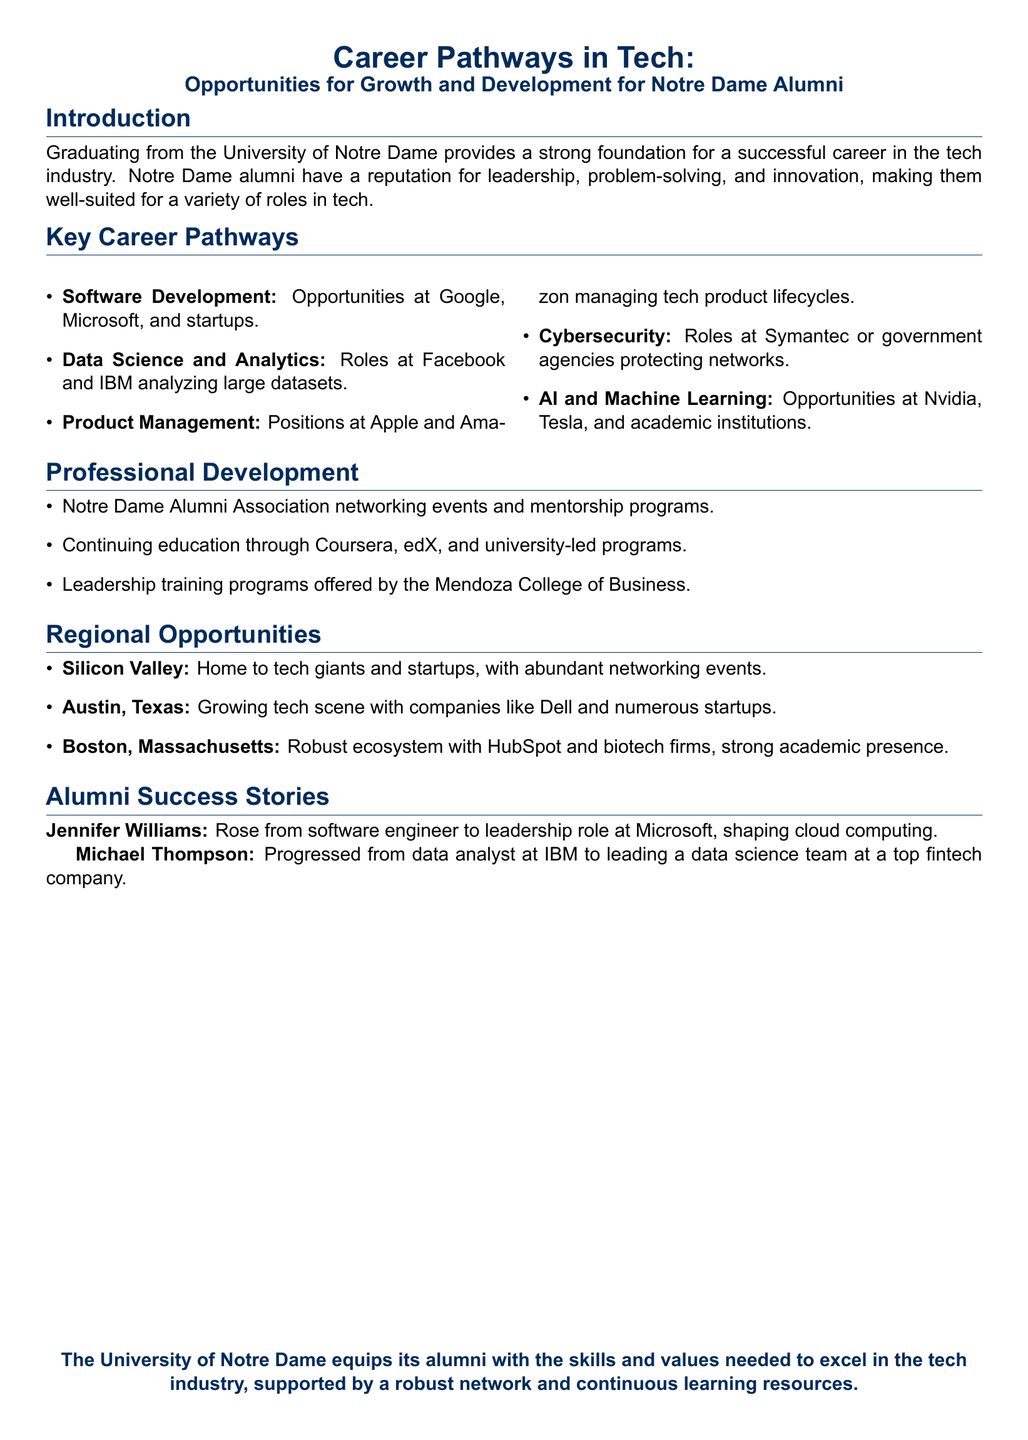What is a key career pathway in tech according to the document? The document lists multiple key career pathways such as Software Development, Data Science and Analytics, etc.
Answer: Software Development Which company is mentioned for opportunities in AI and Machine Learning? The document names specific companies associated with AI and Machine Learning roles, including Nvidia and Tesla.
Answer: Nvidia What type of training programs does the Mendoza College of Business offer? The document refers to specific programs available for professional development, such as leadership training.
Answer: Leadership training Who progressed from a data analyst to a data science team leader? The document highlights specific alumni success stories, including their career progression at notable companies.
Answer: Michael Thompson Which state is recognized for its growing tech scene? The document identifies regions known for tech opportunities, including Austin, Texas, as one of them.
Answer: Texas What is the focus of mentorship programs mentioned in the document? The document emphasizes networking events and mentorship resources available through the Notre Dame Alumni Association.
Answer: Networking How many companies are listed under the Data Science and Analytics pathway? The document mentions specific companies in the Data Science and Analytics section, which includes Facebook and IBM.
Answer: Two What color represents Notre Dame in the document? The document uses specific colors to represent Notre Dame, explicitly mentioning navy and gold.
Answer: Navy 